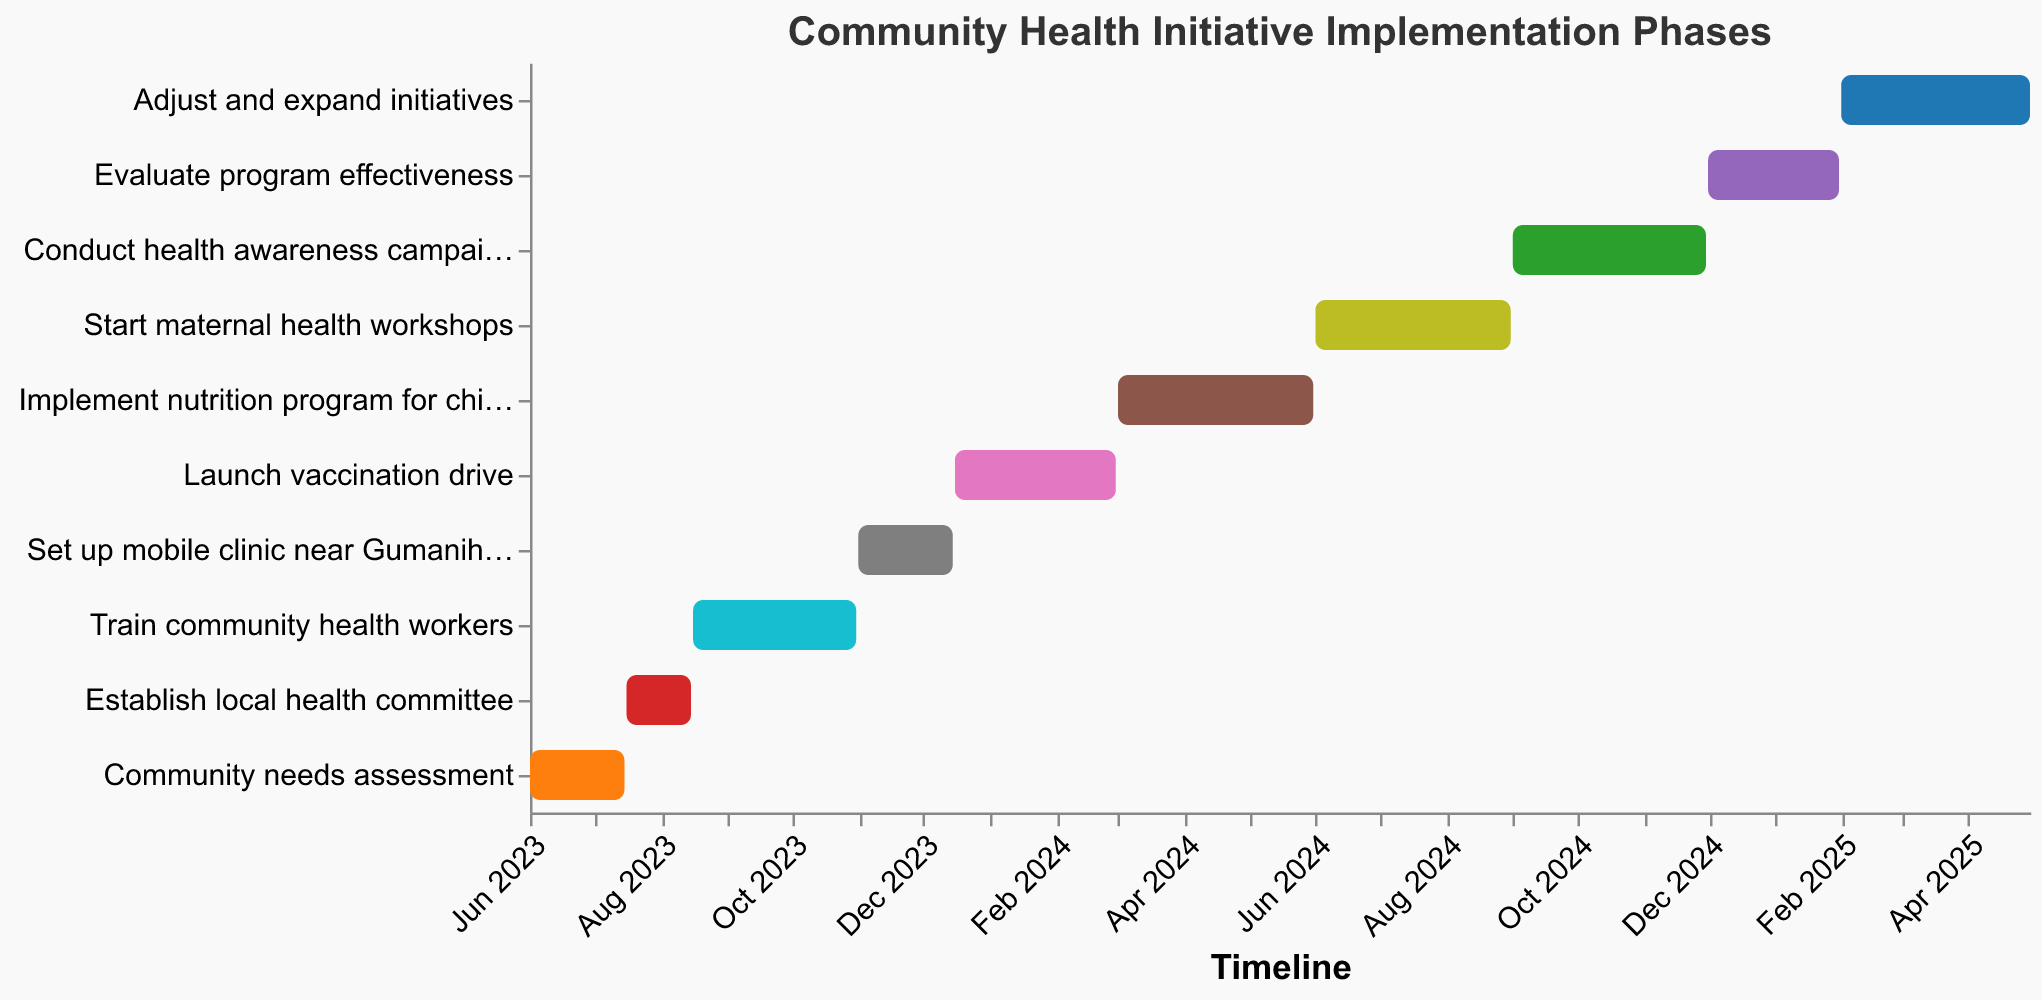Which task starts first? The task starting first will have the earliest date under "Start Date". According to the chart, the "Community needs assessment" starts on June 1, 2023.
Answer: Community needs assessment What is the duration of the "Set up mobile clinic near Gumanihat station" task? To find the duration, calculate the difference between the "Start Date" and "End Date" for the task. The dates are from November 1, 2023, to December 15, 2023.
Answer: 45 days Which tasks are scheduled to run concurrently with the "Launch vaccination drive"? Check the dates for the "Launch vaccination drive" (December 16, 2023, to February 29, 2024) and see which other tasks overlap these dates. "Set up mobile clinic near Gumanihat station" (till December 15, 2023) overlaps initially and "Implement nutrition program for children" starts immediately after, on March 1, 2024.
Answer: None overlap fully How many tasks are planned after the "Train community health workers" task ends? "Train community health workers" ends on October 31, 2023. Count all tasks that start after this date. There are seven tasks after this date.
Answer: 7 tasks Which task has the longest duration? Calculate the duration for each task by finding the difference between the "Start Date" and "End Date". The longest duration is found for the task where the difference is maximum. "Train community health workers" lasts from August 16, 2023, to October 31, 2023, which is 77 days.
Answer: Train community health workers By how many days does the "Implement nutrition program for children" extend beyond the "Launch vaccination drive"? Calculate the end date of "Launch vaccination drive" (February 29, 2024) and the end date for "Implement nutrition program for children" (May 31, 2024). The difference between the two end dates is the required duration.
Answer: 91 days How long will it take to complete the first three tasks? Calculate the duration from the "Start Date" of the first task to the "End Date" of the third task. From June 1, 2023, to October 31, 2023.
Answer: 153 days Which tasks are specifically aimed at addressing maternal and child health? Identify tasks focused on maternal and child health based on their descriptions. "Implement nutrition program for children" and "Start maternal health workshops" are the relevant tasks.
Answer: Implement nutrition program for children, Start maternal health workshops What is the final task in the initiative, and when does it end? The last task listed by date will be the final task. "Adjust and expand initiatives," ending on April 30, 2025, is the final task.
Answer: Adjust and expand initiatives, April 30, 2025 